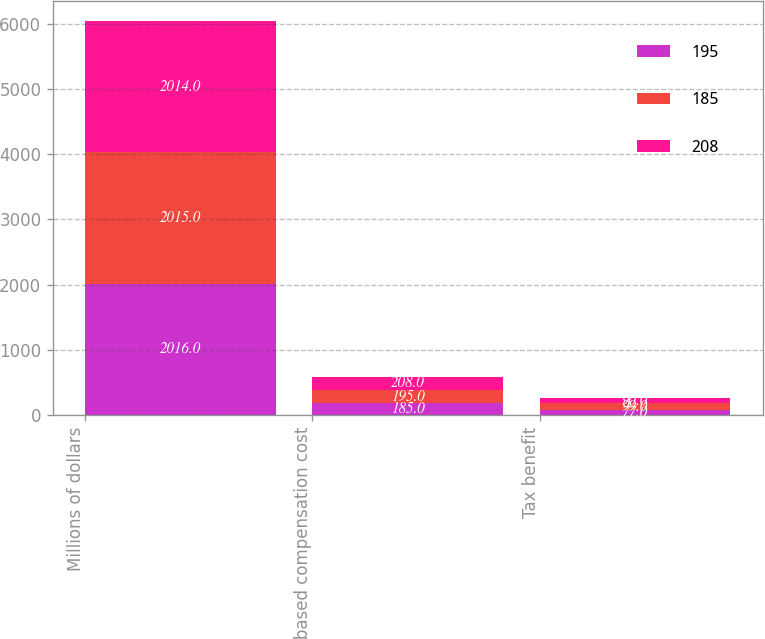Convert chart. <chart><loc_0><loc_0><loc_500><loc_500><stacked_bar_chart><ecel><fcel>Millions of dollars<fcel>Stock-based compensation cost<fcel>Tax benefit<nl><fcel>195<fcel>2016<fcel>185<fcel>77<nl><fcel>185<fcel>2015<fcel>195<fcel>99<nl><fcel>208<fcel>2014<fcel>208<fcel>90<nl></chart> 